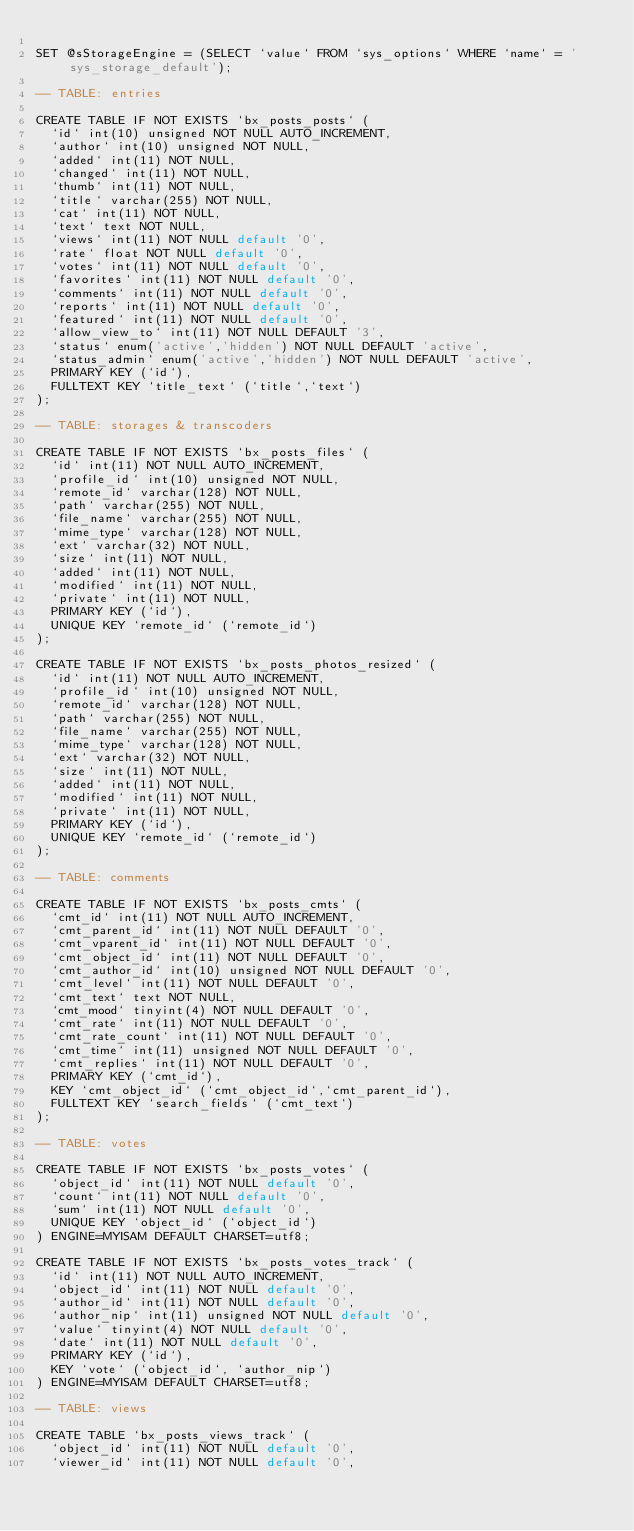<code> <loc_0><loc_0><loc_500><loc_500><_SQL_>
SET @sStorageEngine = (SELECT `value` FROM `sys_options` WHERE `name` = 'sys_storage_default');

-- TABLE: entries

CREATE TABLE IF NOT EXISTS `bx_posts_posts` (
  `id` int(10) unsigned NOT NULL AUTO_INCREMENT,
  `author` int(10) unsigned NOT NULL,
  `added` int(11) NOT NULL,
  `changed` int(11) NOT NULL,
  `thumb` int(11) NOT NULL,
  `title` varchar(255) NOT NULL,
  `cat` int(11) NOT NULL,
  `text` text NOT NULL,
  `views` int(11) NOT NULL default '0',
  `rate` float NOT NULL default '0',
  `votes` int(11) NOT NULL default '0',
  `favorites` int(11) NOT NULL default '0',
  `comments` int(11) NOT NULL default '0',
  `reports` int(11) NOT NULL default '0',
  `featured` int(11) NOT NULL default '0',
  `allow_view_to` int(11) NOT NULL DEFAULT '3',
  `status` enum('active','hidden') NOT NULL DEFAULT 'active',
  `status_admin` enum('active','hidden') NOT NULL DEFAULT 'active',
  PRIMARY KEY (`id`),
  FULLTEXT KEY `title_text` (`title`,`text`)
);

-- TABLE: storages & transcoders

CREATE TABLE IF NOT EXISTS `bx_posts_files` (
  `id` int(11) NOT NULL AUTO_INCREMENT,
  `profile_id` int(10) unsigned NOT NULL,
  `remote_id` varchar(128) NOT NULL,
  `path` varchar(255) NOT NULL,
  `file_name` varchar(255) NOT NULL,
  `mime_type` varchar(128) NOT NULL,
  `ext` varchar(32) NOT NULL,
  `size` int(11) NOT NULL,
  `added` int(11) NOT NULL,
  `modified` int(11) NOT NULL,
  `private` int(11) NOT NULL,
  PRIMARY KEY (`id`),
  UNIQUE KEY `remote_id` (`remote_id`)
);

CREATE TABLE IF NOT EXISTS `bx_posts_photos_resized` (
  `id` int(11) NOT NULL AUTO_INCREMENT,
  `profile_id` int(10) unsigned NOT NULL,
  `remote_id` varchar(128) NOT NULL,
  `path` varchar(255) NOT NULL,
  `file_name` varchar(255) NOT NULL,
  `mime_type` varchar(128) NOT NULL,
  `ext` varchar(32) NOT NULL,
  `size` int(11) NOT NULL,
  `added` int(11) NOT NULL,
  `modified` int(11) NOT NULL,
  `private` int(11) NOT NULL,
  PRIMARY KEY (`id`),
  UNIQUE KEY `remote_id` (`remote_id`)
);

-- TABLE: comments

CREATE TABLE IF NOT EXISTS `bx_posts_cmts` (
  `cmt_id` int(11) NOT NULL AUTO_INCREMENT,
  `cmt_parent_id` int(11) NOT NULL DEFAULT '0',
  `cmt_vparent_id` int(11) NOT NULL DEFAULT '0',
  `cmt_object_id` int(11) NOT NULL DEFAULT '0',
  `cmt_author_id` int(10) unsigned NOT NULL DEFAULT '0',
  `cmt_level` int(11) NOT NULL DEFAULT '0',
  `cmt_text` text NOT NULL,
  `cmt_mood` tinyint(4) NOT NULL DEFAULT '0',
  `cmt_rate` int(11) NOT NULL DEFAULT '0',
  `cmt_rate_count` int(11) NOT NULL DEFAULT '0',
  `cmt_time` int(11) unsigned NOT NULL DEFAULT '0',
  `cmt_replies` int(11) NOT NULL DEFAULT '0',
  PRIMARY KEY (`cmt_id`),
  KEY `cmt_object_id` (`cmt_object_id`,`cmt_parent_id`),
  FULLTEXT KEY `search_fields` (`cmt_text`)
);

-- TABLE: votes

CREATE TABLE IF NOT EXISTS `bx_posts_votes` (
  `object_id` int(11) NOT NULL default '0',
  `count` int(11) NOT NULL default '0',
  `sum` int(11) NOT NULL default '0',
  UNIQUE KEY `object_id` (`object_id`)
) ENGINE=MYISAM DEFAULT CHARSET=utf8;

CREATE TABLE IF NOT EXISTS `bx_posts_votes_track` (
  `id` int(11) NOT NULL AUTO_INCREMENT,
  `object_id` int(11) NOT NULL default '0',
  `author_id` int(11) NOT NULL default '0',
  `author_nip` int(11) unsigned NOT NULL default '0',
  `value` tinyint(4) NOT NULL default '0',
  `date` int(11) NOT NULL default '0',
  PRIMARY KEY (`id`),
  KEY `vote` (`object_id`, `author_nip`)
) ENGINE=MYISAM DEFAULT CHARSET=utf8;

-- TABLE: views

CREATE TABLE `bx_posts_views_track` (
  `object_id` int(11) NOT NULL default '0',
  `viewer_id` int(11) NOT NULL default '0',</code> 